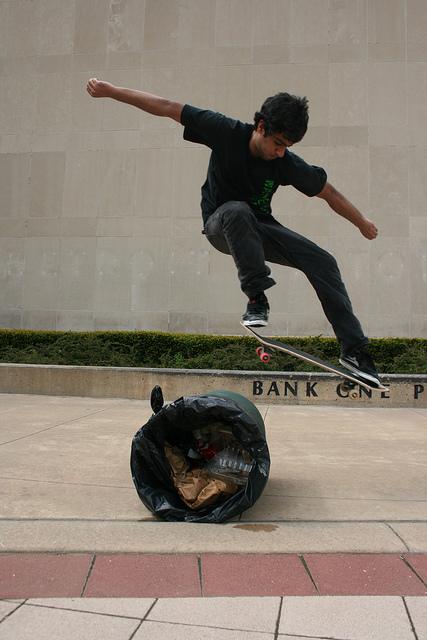What is this person doing?
Quick response, please. Skateboarding. What building  is the person in front of?
Write a very short answer. Bank. Where is the bin?
Concise answer only. On ground. 